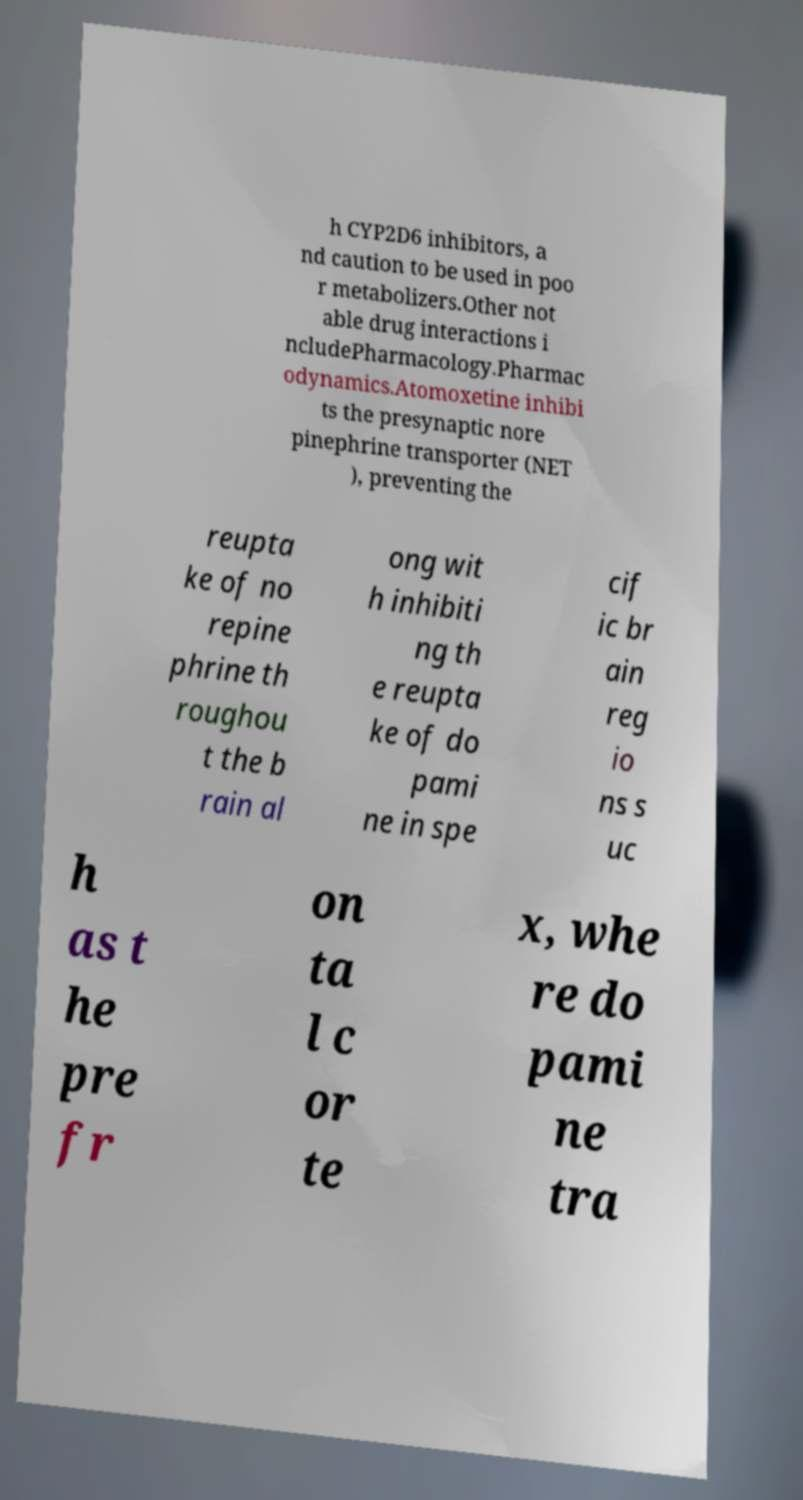Please read and relay the text visible in this image. What does it say? h CYP2D6 inhibitors, a nd caution to be used in poo r metabolizers.Other not able drug interactions i ncludePharmacology.Pharmac odynamics.Atomoxetine inhibi ts the presynaptic nore pinephrine transporter (NET ), preventing the reupta ke of no repine phrine th roughou t the b rain al ong wit h inhibiti ng th e reupta ke of do pami ne in spe cif ic br ain reg io ns s uc h as t he pre fr on ta l c or te x, whe re do pami ne tra 